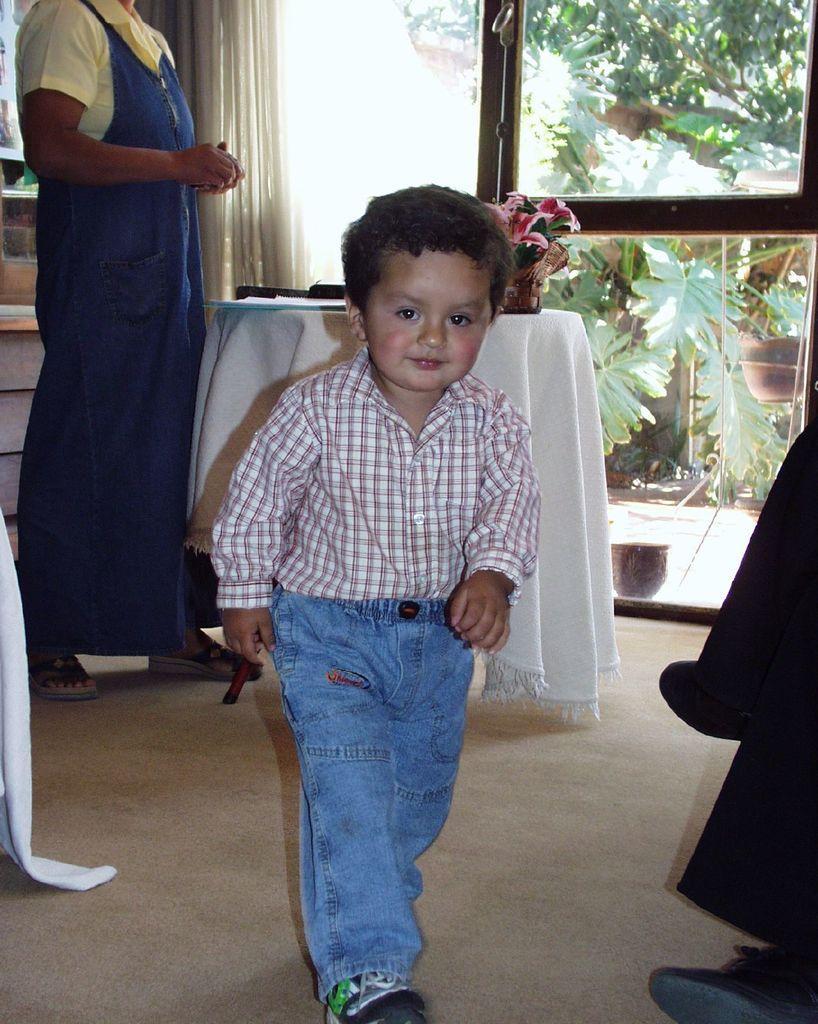In one or two sentences, can you explain what this image depicts? This image consists of a small boy walking. At the bottom, there is a floor. On the left, we can see a woman standing. On the right, there is a door. Behind the boy there is a table covered with a white cloth. On which there is a flower pot. On the right, there is a person sitting. In the background, there are trees and plants. 